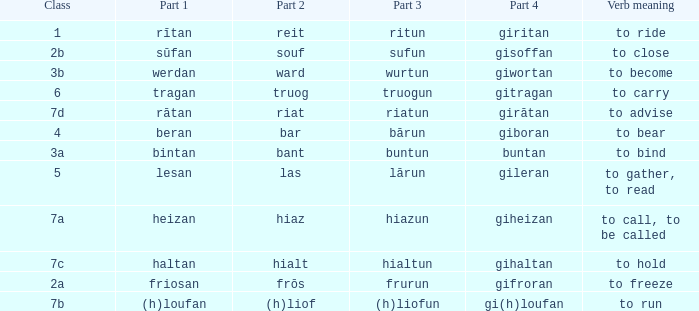What is the verb meaning of the word with part 3 "sufun"? To close. 